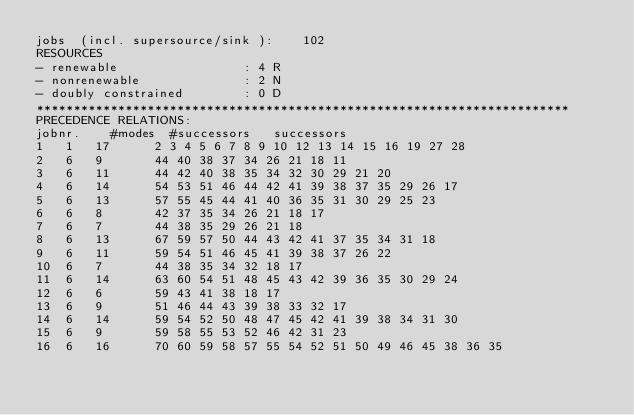Convert code to text. <code><loc_0><loc_0><loc_500><loc_500><_ObjectiveC_>jobs  (incl. supersource/sink ):	102
RESOURCES
- renewable                 : 4 R
- nonrenewable              : 2 N
- doubly constrained        : 0 D
************************************************************************
PRECEDENCE RELATIONS:
jobnr.    #modes  #successors   successors
1	1	17		2 3 4 5 6 7 8 9 10 12 13 14 15 16 19 27 28 
2	6	9		44 40 38 37 34 26 21 18 11 
3	6	11		44 42 40 38 35 34 32 30 29 21 20 
4	6	14		54 53 51 46 44 42 41 39 38 37 35 29 26 17 
5	6	13		57 55 45 44 41 40 36 35 31 30 29 25 23 
6	6	8		42 37 35 34 26 21 18 17 
7	6	7		44 38 35 29 26 21 18 
8	6	13		67 59 57 50 44 43 42 41 37 35 34 31 18 
9	6	11		59 54 51 46 45 41 39 38 37 26 22 
10	6	7		44 38 35 34 32 18 17 
11	6	14		63 60 54 51 48 45 43 42 39 36 35 30 29 24 
12	6	6		59 43 41 38 18 17 
13	6	9		51 46 44 43 39 38 33 32 17 
14	6	14		59 54 52 50 48 47 45 42 41 39 38 34 31 30 
15	6	9		59 58 55 53 52 46 42 31 23 
16	6	16		70 60 59 58 57 55 54 52 51 50 49 46 45 38 36 35 </code> 